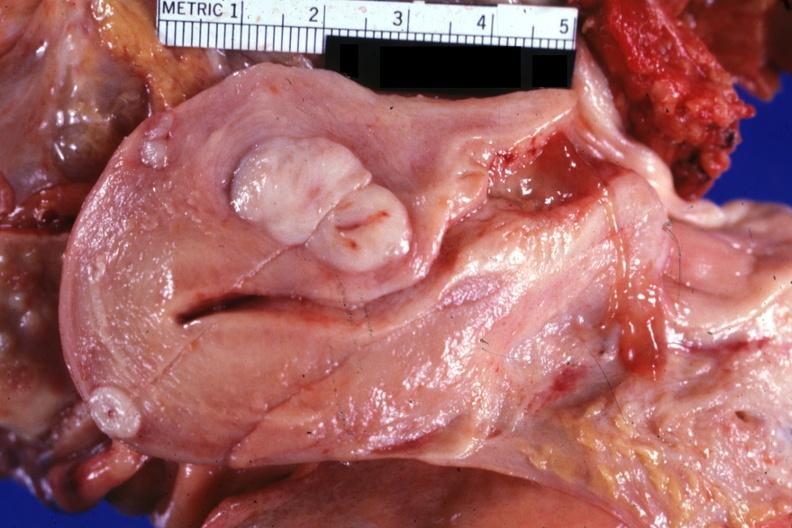where does this part belong to?
Answer the question using a single word or phrase. Female reproductive system 